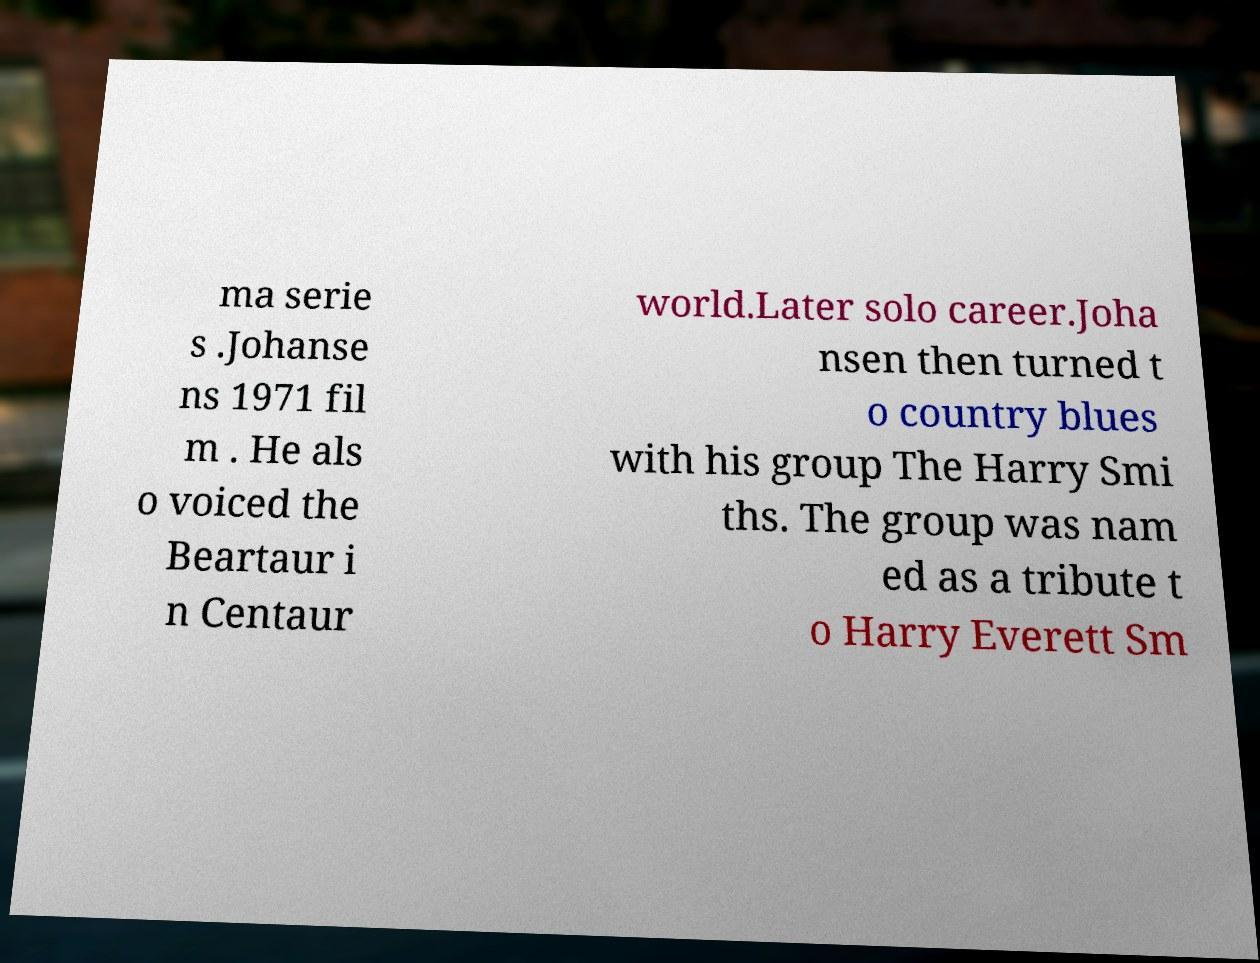Could you extract and type out the text from this image? ma serie s .Johanse ns 1971 fil m . He als o voiced the Beartaur i n Centaur world.Later solo career.Joha nsen then turned t o country blues with his group The Harry Smi ths. The group was nam ed as a tribute t o Harry Everett Sm 